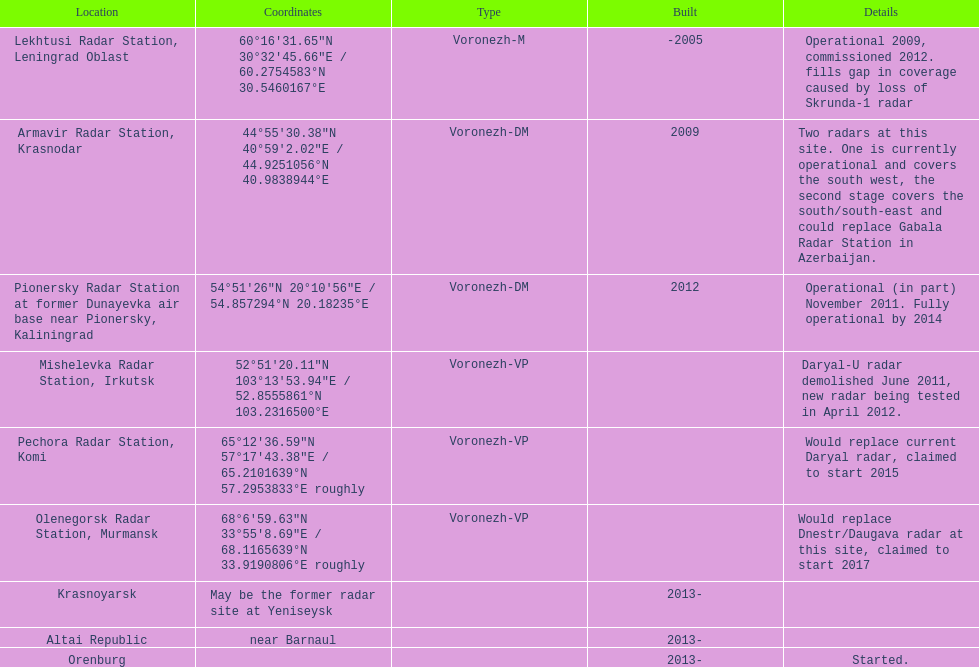5460167°e? Lekhtusi Radar Station, Leningrad Oblast. 